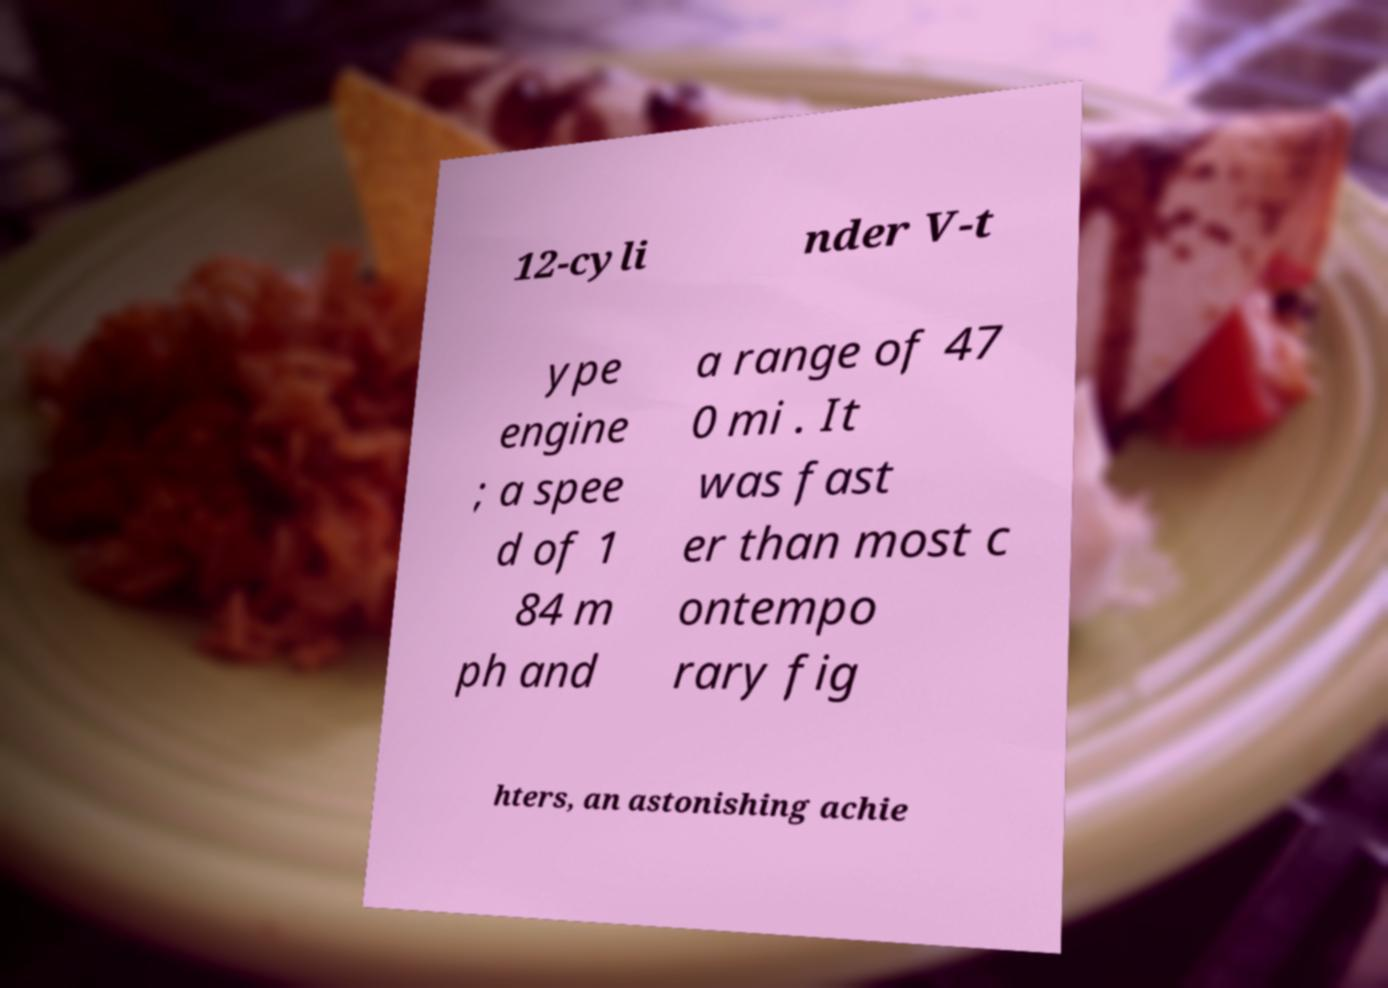For documentation purposes, I need the text within this image transcribed. Could you provide that? 12-cyli nder V-t ype engine ; a spee d of 1 84 m ph and a range of 47 0 mi . It was fast er than most c ontempo rary fig hters, an astonishing achie 